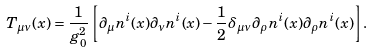Convert formula to latex. <formula><loc_0><loc_0><loc_500><loc_500>T _ { \mu \nu } ( x ) = \frac { 1 } { g _ { 0 } ^ { 2 } } \left [ \partial _ { \mu } n ^ { i } ( x ) \partial _ { \nu } n ^ { i } ( x ) - \frac { 1 } { 2 } \delta _ { \mu \nu } \partial _ { \rho } n ^ { i } ( x ) \partial _ { \rho } n ^ { i } ( x ) \right ] .</formula> 